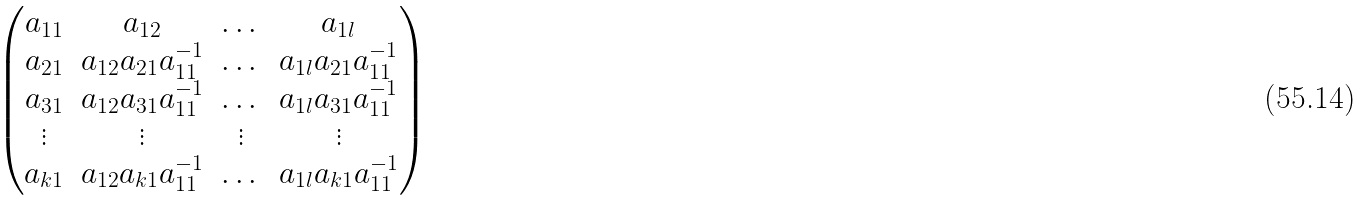Convert formula to latex. <formula><loc_0><loc_0><loc_500><loc_500>\begin{pmatrix} a _ { 1 1 } & a _ { 1 2 } & \dots & a _ { 1 l } \\ a _ { 2 1 } & a _ { 1 2 } a _ { 2 1 } a _ { 1 1 } ^ { - 1 } & \dots & a _ { 1 l } a _ { 2 1 } a _ { 1 1 } ^ { - 1 } \\ a _ { 3 1 } & a _ { 1 2 } a _ { 3 1 } a _ { 1 1 } ^ { - 1 } & \dots & a _ { 1 l } a _ { 3 1 } a _ { 1 1 } ^ { - 1 } \\ \vdots & \vdots & \vdots & \vdots \\ a _ { k 1 } & a _ { 1 2 } a _ { k 1 } a _ { 1 1 } ^ { - 1 } & \dots & a _ { 1 l } a _ { k 1 } a _ { 1 1 } ^ { - 1 } \\ \end{pmatrix}</formula> 